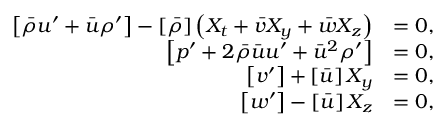<formula> <loc_0><loc_0><loc_500><loc_500>\begin{array} { r l } { \left [ \bar { \rho } u ^ { \prime } + \bar { u } \rho ^ { \prime } \right ] - \left [ \bar { \rho } \right ] \left ( X _ { t } + \bar { v } X _ { y } + \bar { w } X _ { z } \right ) } & { = 0 , } \\ { \left [ p ^ { \prime } + 2 \bar { \rho } \bar { u } u ^ { \prime } + \bar { u } ^ { 2 } \rho ^ { \prime } \right ] } & { = 0 , } \\ { \left [ v ^ { \prime } \right ] + \left [ \bar { u } \right ] X _ { y } } & { = 0 , } \\ { \left [ w ^ { \prime } \right ] - \left [ \bar { u } \right ] X _ { z } } & { = 0 , } \end{array}</formula> 